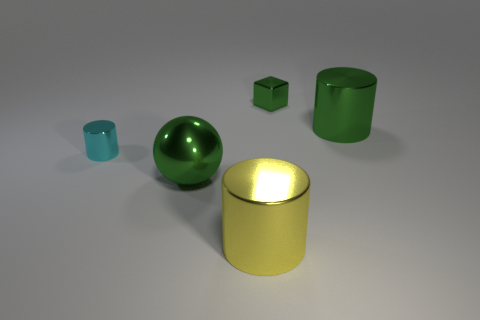What is the material of the green object that is the same shape as the yellow object?
Your answer should be very brief. Metal. There is a big metallic cylinder behind the large metallic object that is in front of the large metal sphere; are there any tiny cyan shiny cylinders left of it?
Keep it short and to the point. Yes. There is a big object that is behind the yellow shiny object and to the left of the green shiny cube; what is its shape?
Offer a terse response. Sphere. Is there another shiny cube that has the same color as the metal cube?
Offer a very short reply. No. What color is the tiny metallic thing that is on the left side of the metallic cylinder that is in front of the green metal sphere?
Your answer should be very brief. Cyan. What is the size of the green shiny object on the left side of the big metallic cylinder on the left side of the big metal thing behind the sphere?
Your answer should be compact. Large. Does the big green cylinder have the same material as the cylinder in front of the green sphere?
Make the answer very short. Yes. What size is the cyan thing that is made of the same material as the green ball?
Give a very brief answer. Small. Is there another small green metal thing that has the same shape as the tiny green metal object?
Provide a succinct answer. No. How many objects are either objects that are in front of the tiny cube or small rubber balls?
Provide a succinct answer. 4. 